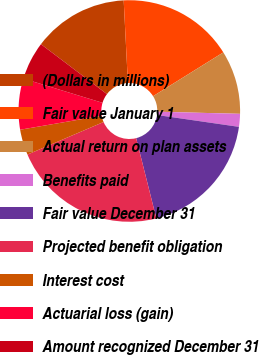Convert chart to OTSL. <chart><loc_0><loc_0><loc_500><loc_500><pie_chart><fcel>(Dollars in millions)<fcel>Fair value January 1<fcel>Actual return on plan assets<fcel>Benefits paid<fcel>Fair value December 31<fcel>Projected benefit obligation<fcel>Interest cost<fcel>Actuarial loss (gain)<fcel>Amount recognized December 31<nl><fcel>13.89%<fcel>16.94%<fcel>9.28%<fcel>1.88%<fcel>18.79%<fcel>22.49%<fcel>3.73%<fcel>7.43%<fcel>5.58%<nl></chart> 